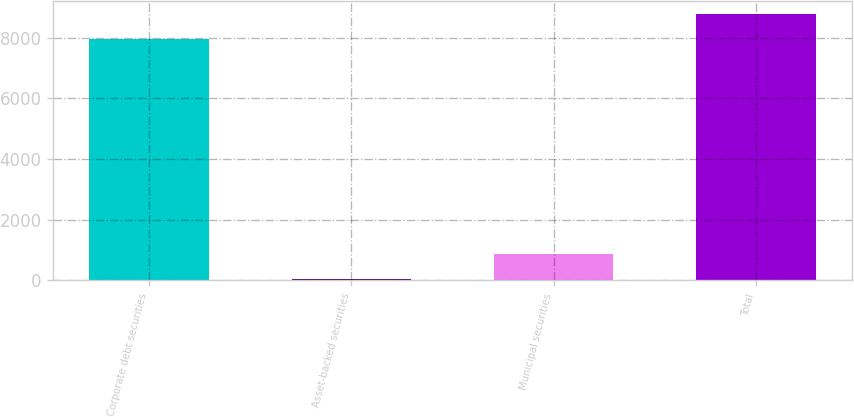<chart> <loc_0><loc_0><loc_500><loc_500><bar_chart><fcel>Corporate debt securities<fcel>Asset-backed securities<fcel>Municipal securities<fcel>Total<nl><fcel>7966<fcel>54<fcel>858.7<fcel>8770.7<nl></chart> 